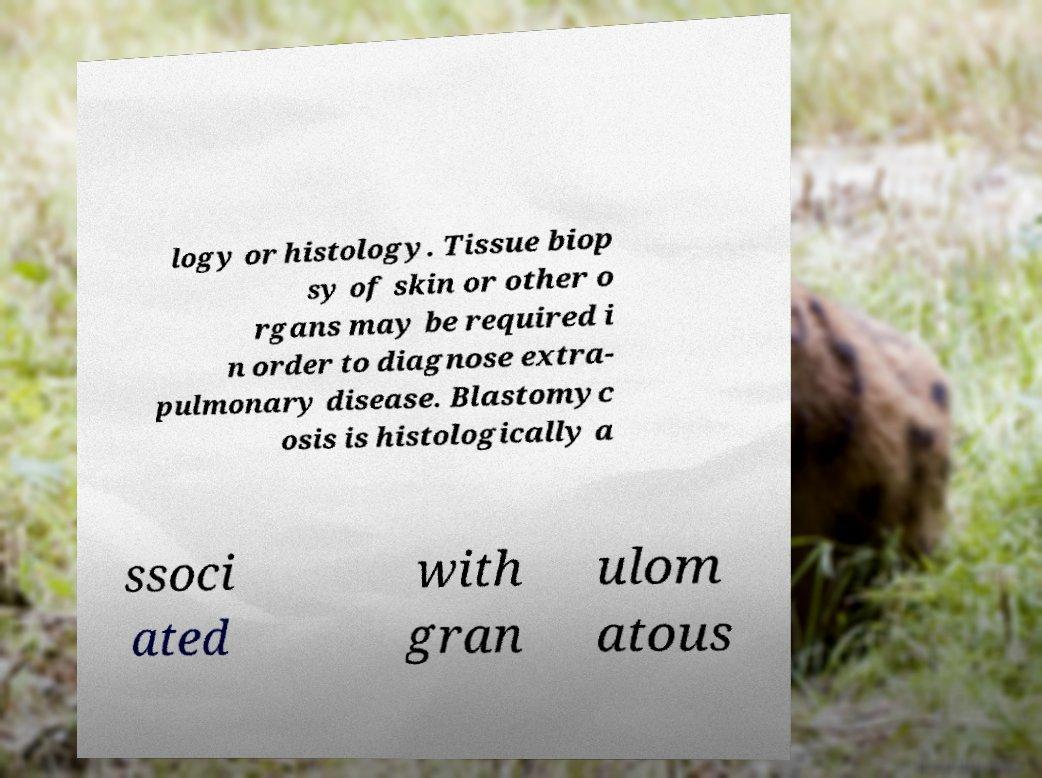There's text embedded in this image that I need extracted. Can you transcribe it verbatim? logy or histology. Tissue biop sy of skin or other o rgans may be required i n order to diagnose extra- pulmonary disease. Blastomyc osis is histologically a ssoci ated with gran ulom atous 